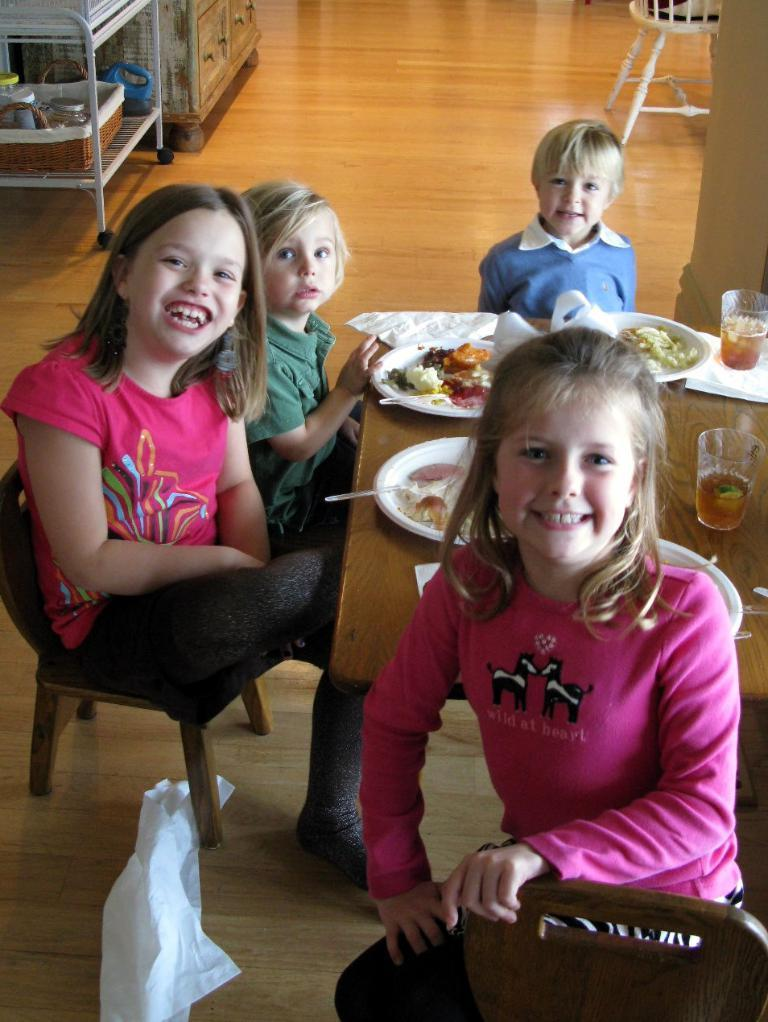How many people are in the image? There are three people in the image. What are the people doing in the image? The people are sitting on chairs. Where are the chairs located in relation to each other? The chairs are around a table. Which person is sitting on the right side? A kid is sitting on the right side. What can be found on the table besides the chairs? There are glasses and food items on the table. What type of engine can be seen powering the dock in the image? There is no engine or dock present in the image; it features three people sitting around a table with glasses and food items. 